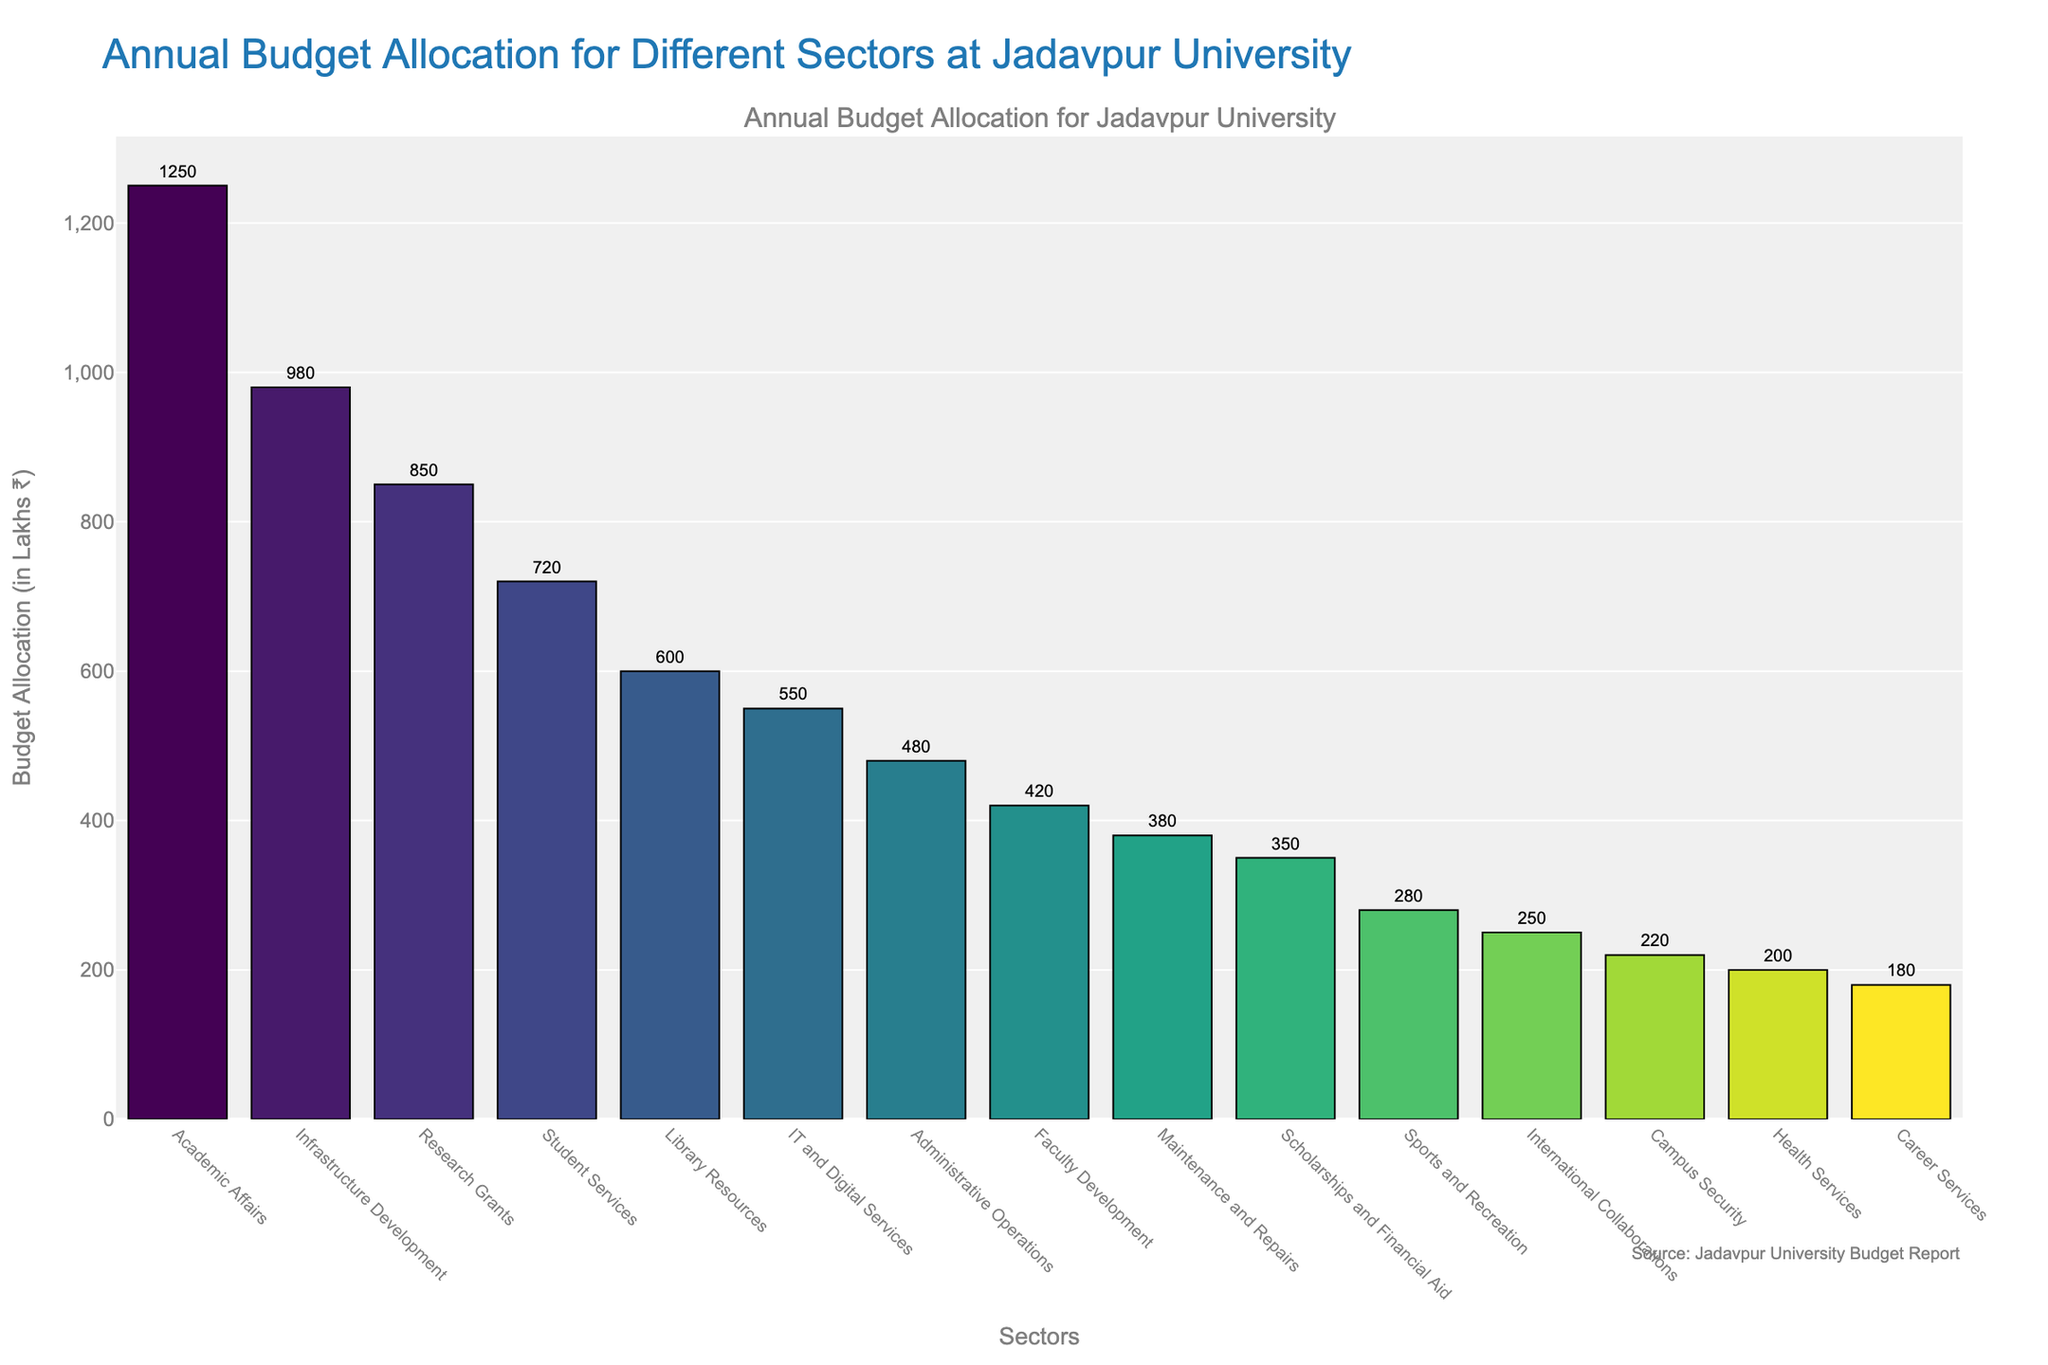Which sector has the highest budget allocation? The bar corresponding to "Academic Affairs" is the tallest, indicating it has the highest budget allocation.
Answer: Academic Affairs What is the budget allocation for Health Services? By reading the label text associated with the "Health Services" bar, the budget allocation is ₹200 Lakhs.
Answer: ₹200 Lakhs Compare the budget allocations for Research Grants and Faculty Development. Which one is higher, and by how much? The bar for "Research Grants" extends to ₹850 Lakhs, and the bar for "Faculty Development" extends to ₹420 Lakhs. The difference is 850 - 420 = ₹430 Lakhs.
Answer: Research Grants by ₹430 Lakhs What is the total budget allocation for sectors related to student welfare (Student Services, Scholarships and Financial Aid, Sports and Recreation, Career Services)? Sum the allocations of these sectors: 720 (Student Services) + 350 (Scholarships and Financial Aid) + 280 (Sports and Recreation) + 180 (Career Services) = ₹1530 Lakhs
Answer: ₹1530 Lakhs Which sectors allocate less than ₹500 Lakhs, and what is their combined budget allocation? The sectors with less than ₹500 Lakhs allocation have bars reaching <500: Administrative Operations (480), Faculty Development (420), Maintenance and Repairs (380), Scholarships and Financial Aid (350), Sports and Recreation (280), International Collaborations (250), Campus Security (220), Health Services (200), and Career Services (180). Combined allocation: 480 + 420 + 380 + 350 + 280 + 250 + 220 + 200 + 180 = ₹2760 Lakhs
Answer: ₹2760 Lakhs How many sectors have a budget allocation greater than or equal to ₹600 Lakhs? Sectors with bars extending equal to or above the ₹600 Lakhs line are Academic Affairs, Infrastructure Development, Research Grants, Student Services, and Library Resources.
Answer: 5 What is the difference in budget allocations between the highest and the lowest sector? The highest allocation is ₹1250 Lakhs (Academic Affairs), and the lowest is ₹180 Lakhs (Career Services). The difference is 1250 - 180 = ₹1070 Lakhs.
Answer: ₹1070 Lakhs What is the average budget allocation for all sectors displayed? Sum of all allocations: 1250 + 980 + 850 + 720 + 600 + 550 + 480 + 420 + 380 + 350 + 280 + 250 + 220 + 200 + 180 = ₹7710 Lakhs. Divide this by the number of sectors: 7710 / 15 = ₹514 Lakhs.
Answer: ₹514 Lakhs Which sectors' bars have a noticeable color difference indicating different levels of budget allocation around mid-value (500-600)? The bars for IT and Digital Services (₹550 Lakhs) and Library Resources (₹600 Lakhs) exhibit different colors indicative of this budget range.
Answer: IT and Digital Services, Library Resources Is the budget allocation for Infrastructure Development more than double that of Career Services? Infrastructure Development has ₹980 Lakhs while Career Services has ₹180 Lakhs. Twice 180 is 360, and 980 > 360.
Answer: Yes 